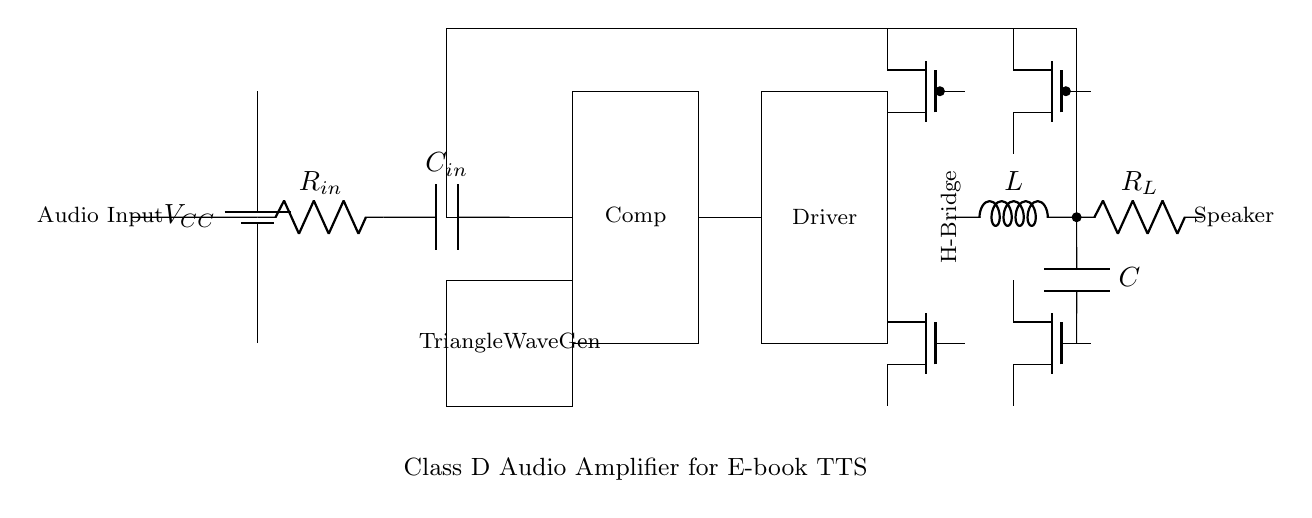What is the type of amplifier represented in this circuit? The circuit represents a Class D amplifier, which is indicated by the H-Bridge output stage and the overall structure designed for efficient audio amplification.
Answer: Class D What are the components in the input stage? The input stage includes a resistor and a capacitor, shown as R_in and C_in respectively, connected to the audio input signal.
Answer: R_in, C_in What component is used to generate the triangle wave? The triangle wave generator is denoted in the circuit and is a rectangle containing the label 'Triangle Wave Gen', indicating its function to provide a triangular waveform for PWM modulation.
Answer: Triangle Wave Gen How many transistors are used in the output stage? The output stage consists of four transistors, specifically two N-channel and two P-channel MOSFETs, collectively forming an H-bridge configuration for driving the load.
Answer: Four What is the purpose of the feedback loop in this circuit? The feedback loop connects the load back to the input stage, allowing for error correction and improved control over the amplifier output, ensuring a more accurate reproduction of the input signal.
Answer: Error correction What is connected to the output of the H-Bridge? At the output of the H-Bridge, an inductor and a speaker are connected, indicating that the amplifier is driving an inductive load typically used in audio applications.
Answer: Inductor, Speaker What is the significance of using a Class D amplifier for text-to-speech applications? The significance lies in its high efficiency and ability to produce excellent audio quality with less heat dissipation, making it suitable for battery-operated devices like e-readers.
Answer: High efficiency 